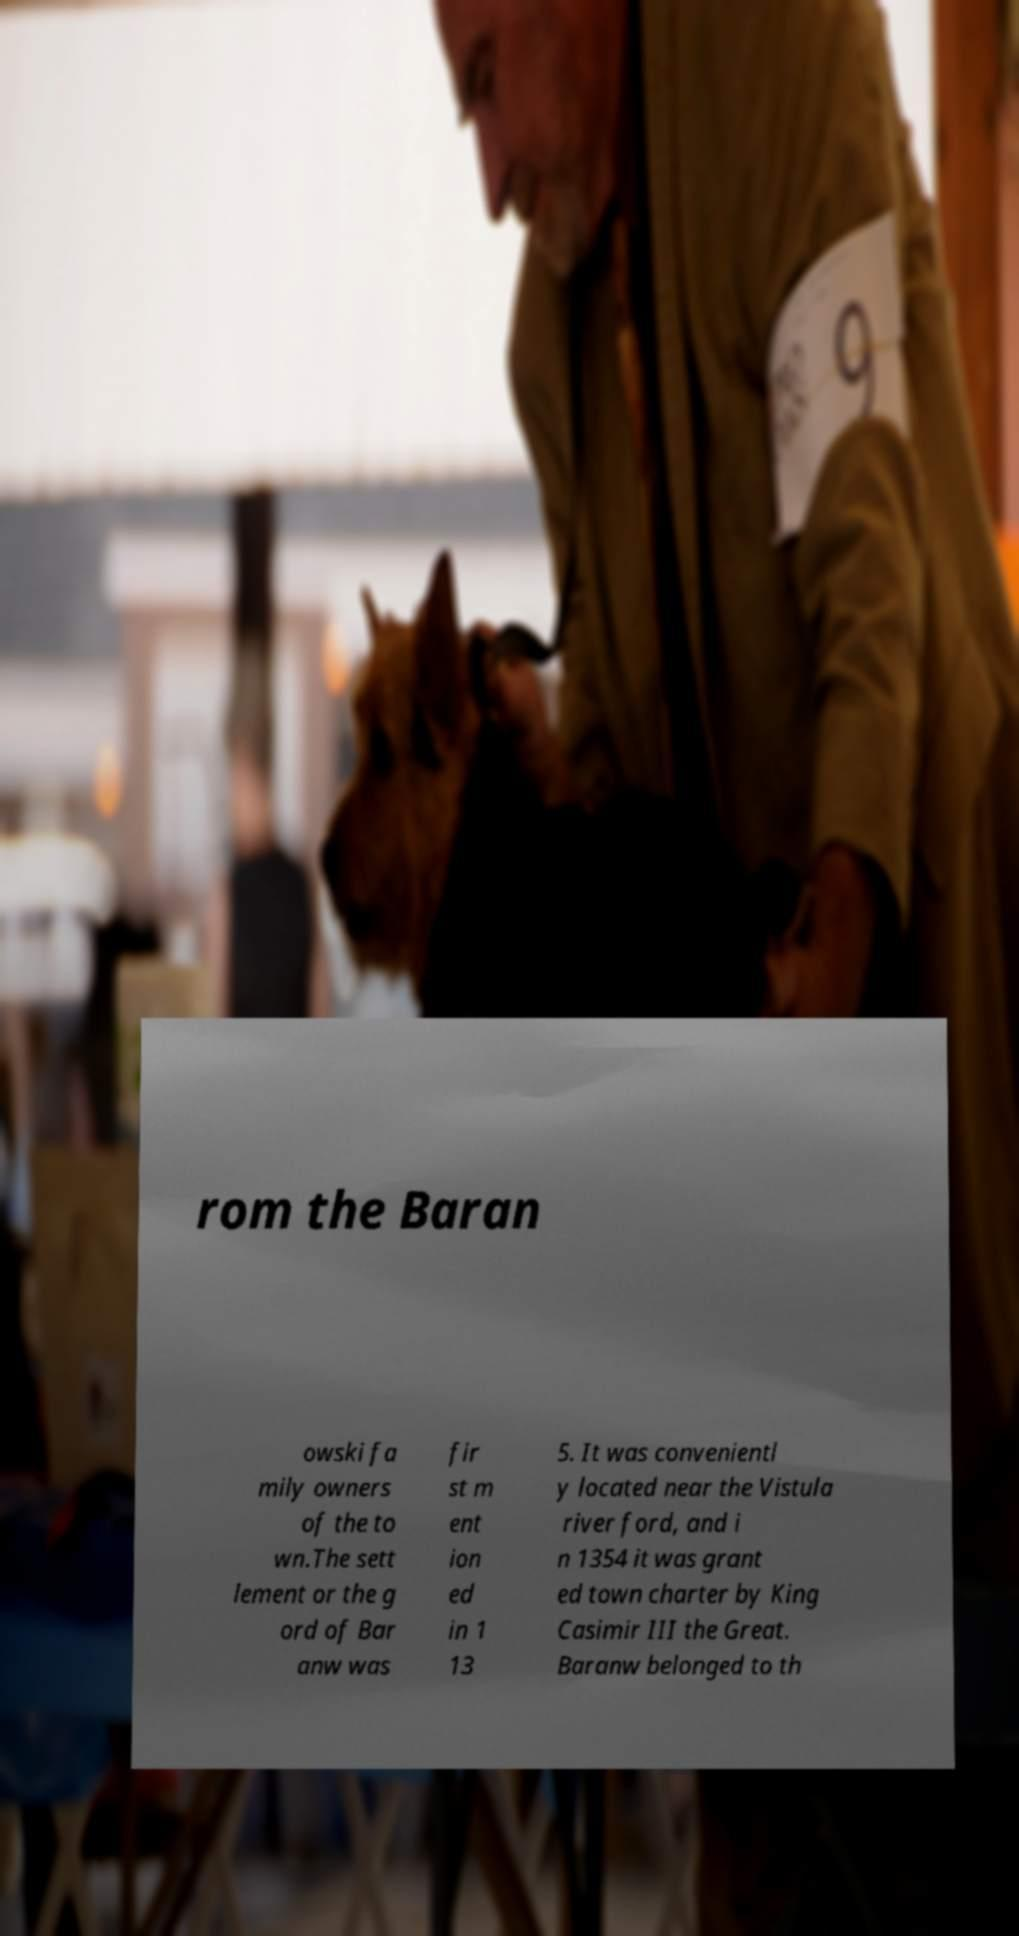I need the written content from this picture converted into text. Can you do that? rom the Baran owski fa mily owners of the to wn.The sett lement or the g ord of Bar anw was fir st m ent ion ed in 1 13 5. It was convenientl y located near the Vistula river ford, and i n 1354 it was grant ed town charter by King Casimir III the Great. Baranw belonged to th 